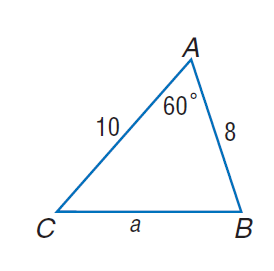Answer the mathemtical geometry problem and directly provide the correct option letter.
Question: Find a if c = 8, b = 10, and m \angle A = 60.
Choices: A: 4.6 B: 5.9 C: 7.2 D: 9.2 D 